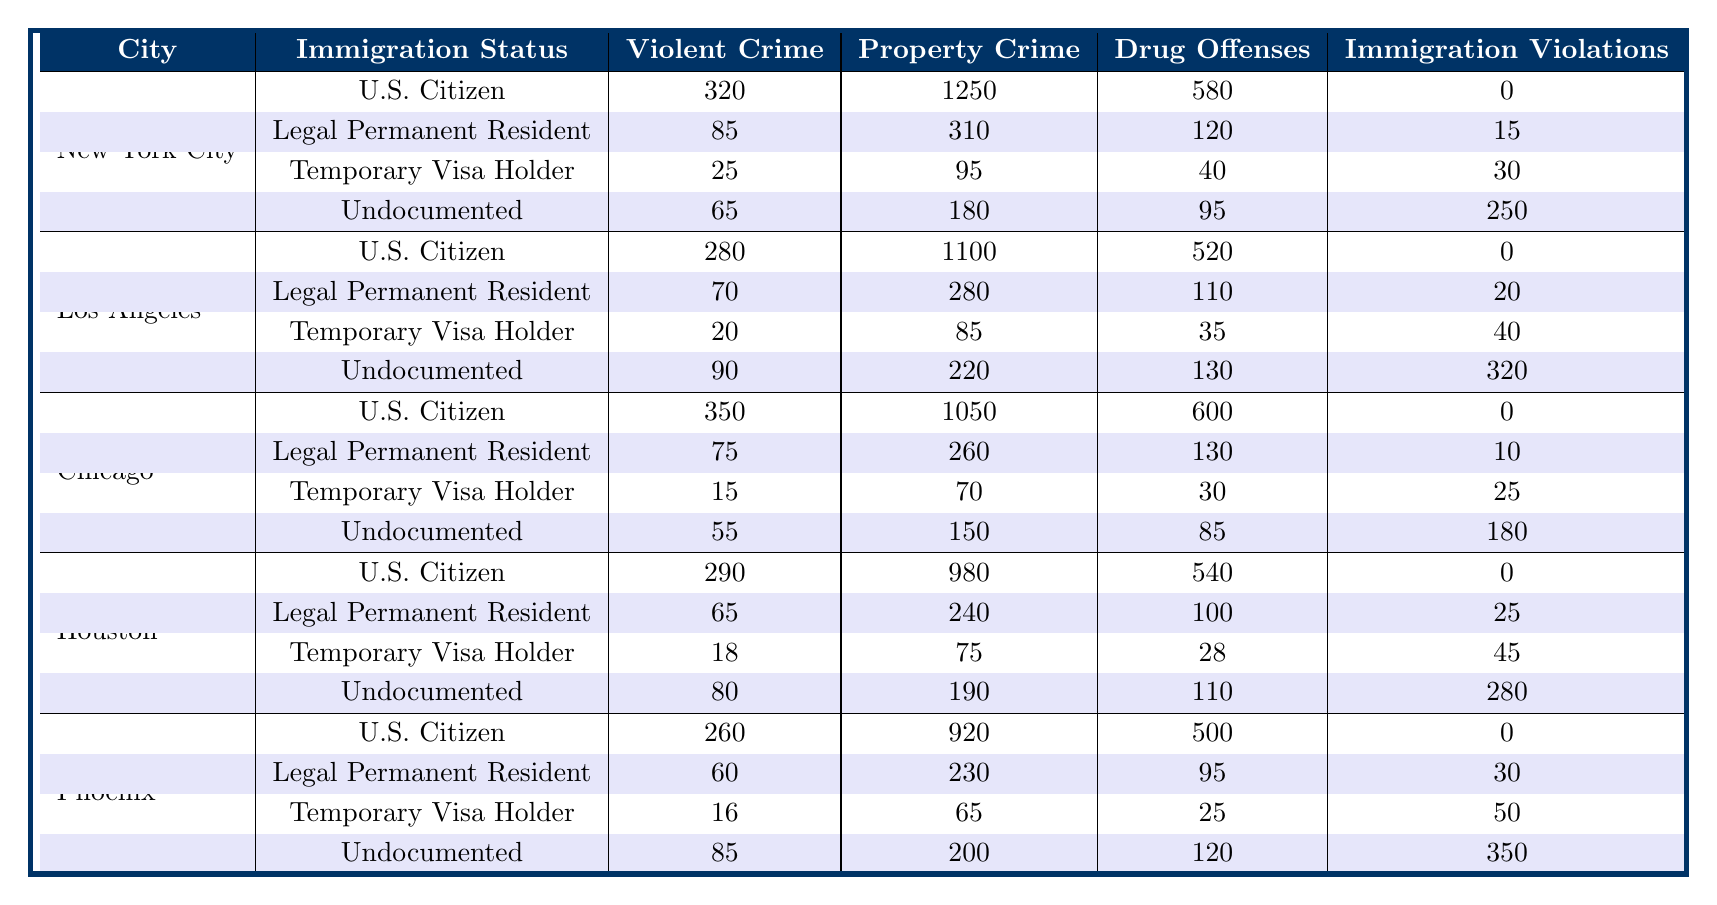What is the total number of violent crimes committed by U.S. Citizens in New York City? According to the table, the number of violent crimes committed by U.S. Citizens in New York City is 320.
Answer: 320 How many violent crimes are reported by undocumented individuals in Los Angeles? The table shows that undocumented individuals in Los Angeles committed 90 violent crimes.
Answer: 90 What is the difference in property crime rates between Temporary Visa Holders and Legal Permanent Residents in Chicago? Temporary Visa Holders committed 70 property crimes while Legal Permanent Residents committed 260 property crimes in Chicago. The difference is 260 - 70 = 190.
Answer: 190 Which immigration status reported the highest number of drug offenses in Phoenix? The U.S. Citizens reported 500 drug offenses in Phoenix, which is the highest compared to other statuses provided.
Answer: U.S. Citizen Are there more immigration violations among undocumented immigrants or temporary visa holders in Houston? In Houston, undocumented immigrants had 280 immigration violations, while temporary visa holders had 45. Since 280 is greater than 45, undocumented immigrants had more violations.
Answer: Undocumented immigrants What is the combined total of violent crimes for all immigration statuses in Chicago? To find the total, we sum the violent crimes: 350 (U.S. Citizen) + 75 (Legal Permanent Resident) + 15 (Temporary Visa Holder) + 55 (Undocumented) = 495.
Answer: 495 Is there a higher number of immigration violations in New York City or Los Angeles? In New York City, there were 295 immigration violations (0 + 15 + 30 + 250), whereas in Los Angeles there were 320 (0 + 20 + 40 + 320). Since 320 > 295, Los Angeles has more immigration violations.
Answer: Los Angeles What is the average number of property crimes committed by Legal Permanent Residents across all cities? The property crimes committed by Legal Permanent Residents total: 310 (NYC) + 280 (LA) + 260 (Chicago) + 240 (Houston) + 230 (Phoenix) = 1320. The average is 1320/5 = 264.
Answer: 264 In which city did Temporary Visa Holders commit the least number of drug offenses? By comparing the drug offenses by Temporary Visa Holders: NYC (40), LA (35), Chicago (30), Houston (28), and Phoenix (25). The least is 25 in Phoenix.
Answer: Phoenix What percentage of the total violent crimes in Houston were committed by U.S. Citizens? The total violent crimes in Houston is 290 (U.S. Citizen) + 65 (Legal Permanent Resident) + 18 (Temporary Visa Holder) + 80 (Undocumented) = 453. The percentage for U.S. Citizens is (290/453) * 100 = 64.1%.
Answer: 64.1% 